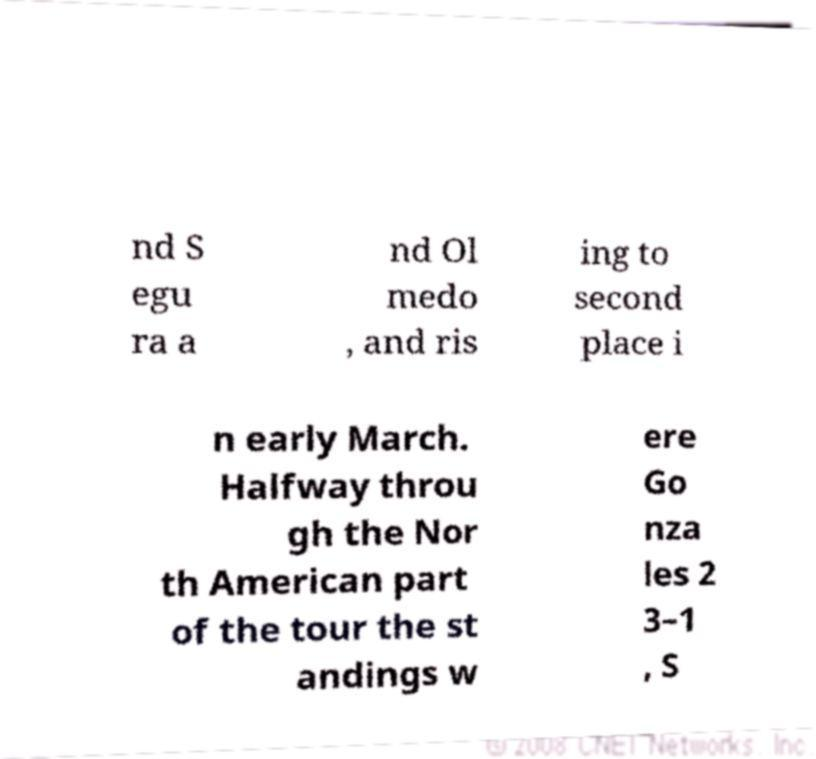What messages or text are displayed in this image? I need them in a readable, typed format. nd S egu ra a nd Ol medo , and ris ing to second place i n early March. Halfway throu gh the Nor th American part of the tour the st andings w ere Go nza les 2 3–1 , S 